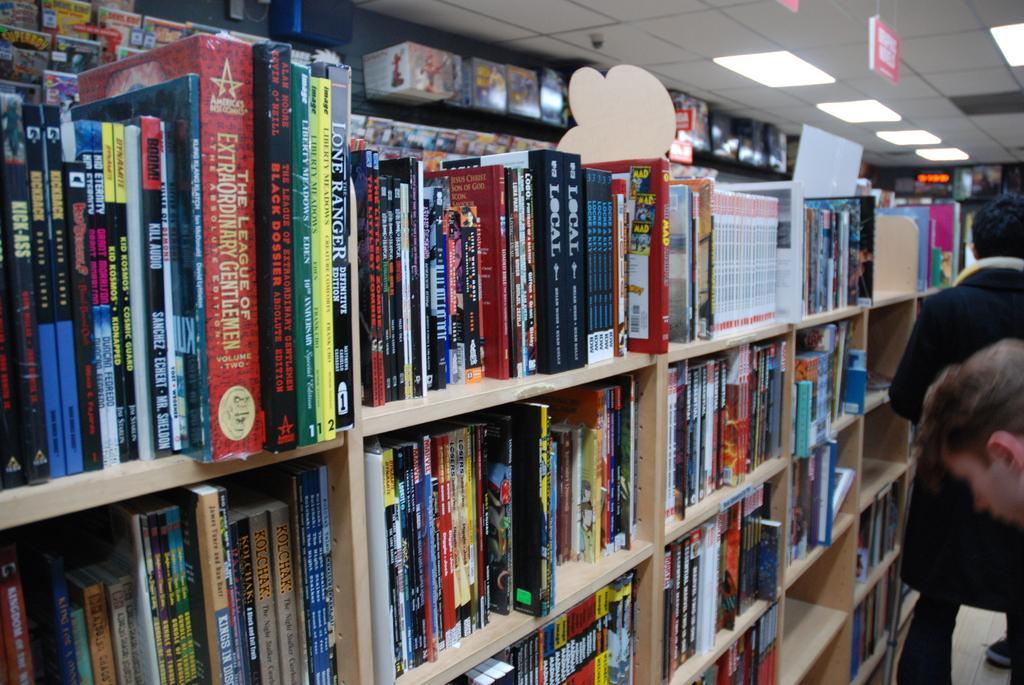How would you summarize this image in a sentence or two? Here I can see many books arranged in the racks. It seems to be a library. On the right side, I can see two persons. At the top of the image there are few lights to the roof. 